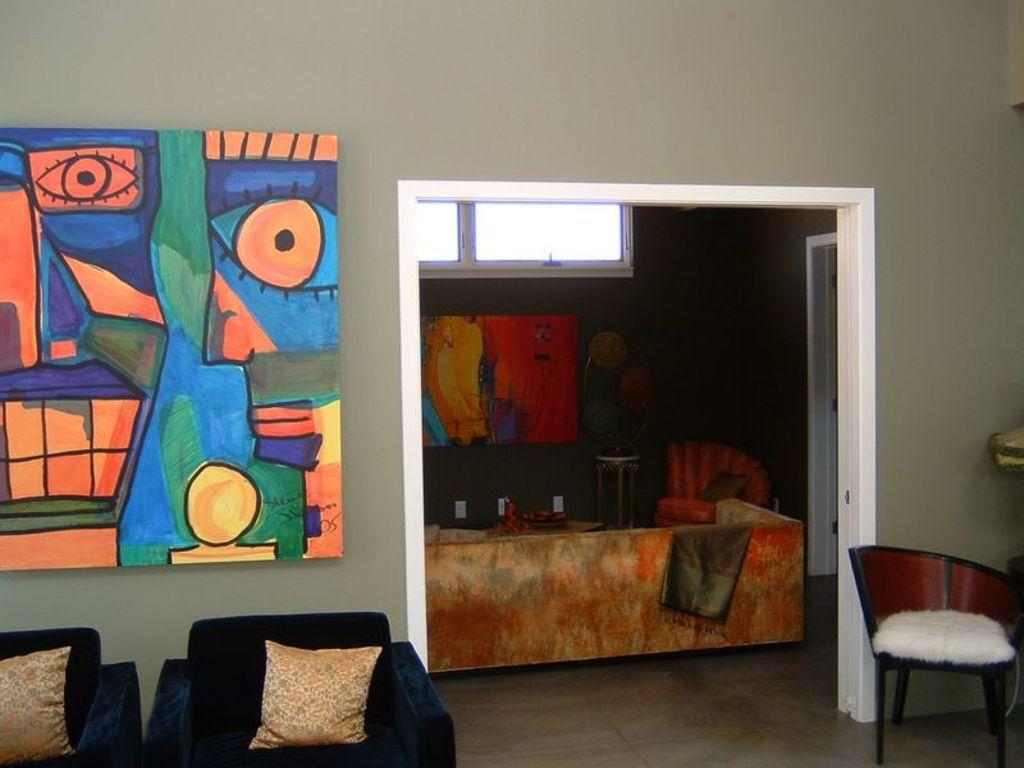What type of space is depicted in the image? There is a room in the image. What furniture is present in the room? There is a couch and a chair in the room. Is there any additional feature on the wall in the room? Yes, there is a board attached to the wall in the room. Can you see any blades on the couch in the image? There are no blades visible on the couch in the image. Is there an island in the room in the image? There is no island present in the room in the image. 